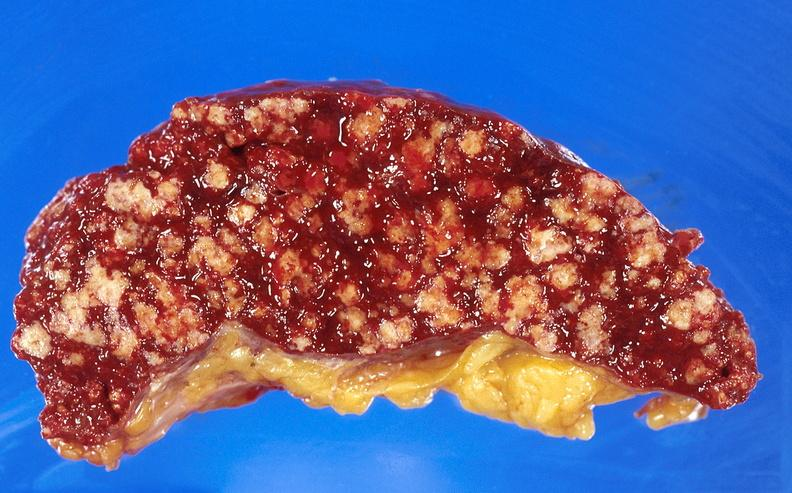s close-up excellent example of interosseous muscle atrophy present?
Answer the question using a single word or phrase. No 